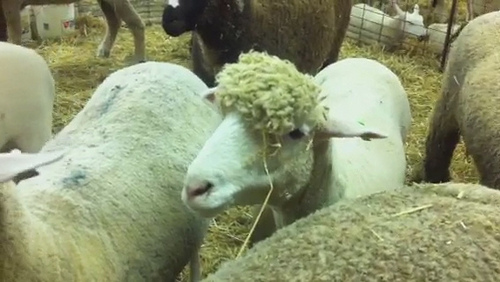What is the animal that is standing in the pen? The animal standing in the pen is a sheep. 